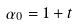Convert formula to latex. <formula><loc_0><loc_0><loc_500><loc_500>\alpha _ { 0 } = 1 + t</formula> 